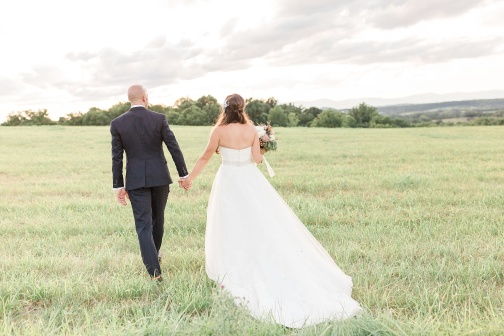What kind of journey do you think this couple is on? The couple in the image seems to be on the journey of marriage, symbolized by their wedding attire and the serene environment. They are walking hand in hand, suggesting companionship and mutual support as they step into the new chapter of their lives together. 